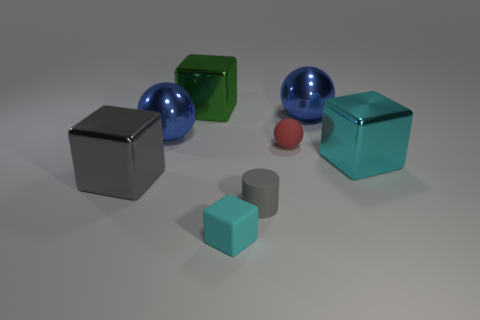Add 1 shiny cubes. How many objects exist? 9 Subtract all purple balls. Subtract all cyan cubes. How many balls are left? 3 Subtract all balls. How many objects are left? 5 Add 2 big cyan blocks. How many big cyan blocks exist? 3 Subtract 2 cyan blocks. How many objects are left? 6 Subtract all brown metal things. Subtract all large metal spheres. How many objects are left? 6 Add 7 large gray cubes. How many large gray cubes are left? 8 